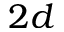Convert formula to latex. <formula><loc_0><loc_0><loc_500><loc_500>2 d</formula> 